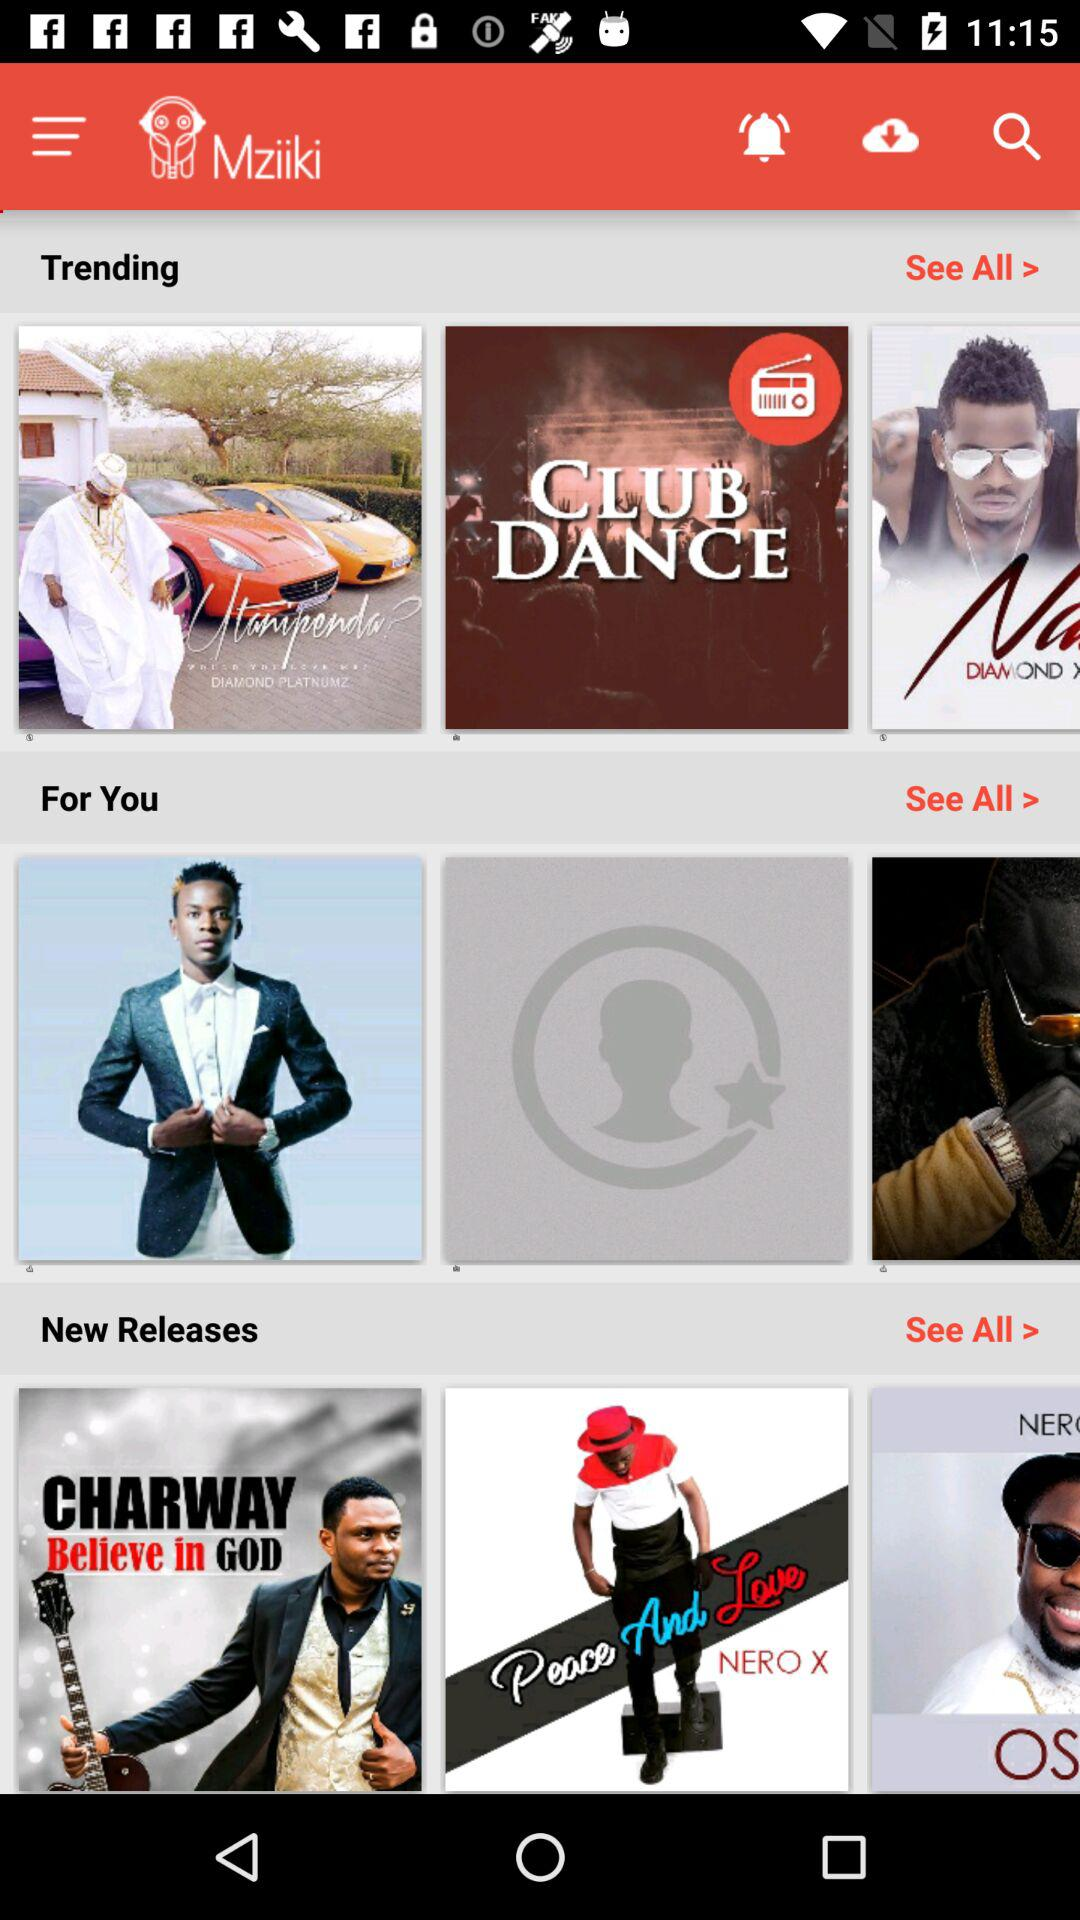How many items in the 'For You' section have a picture of a person?
Answer the question using a single word or phrase. 2 